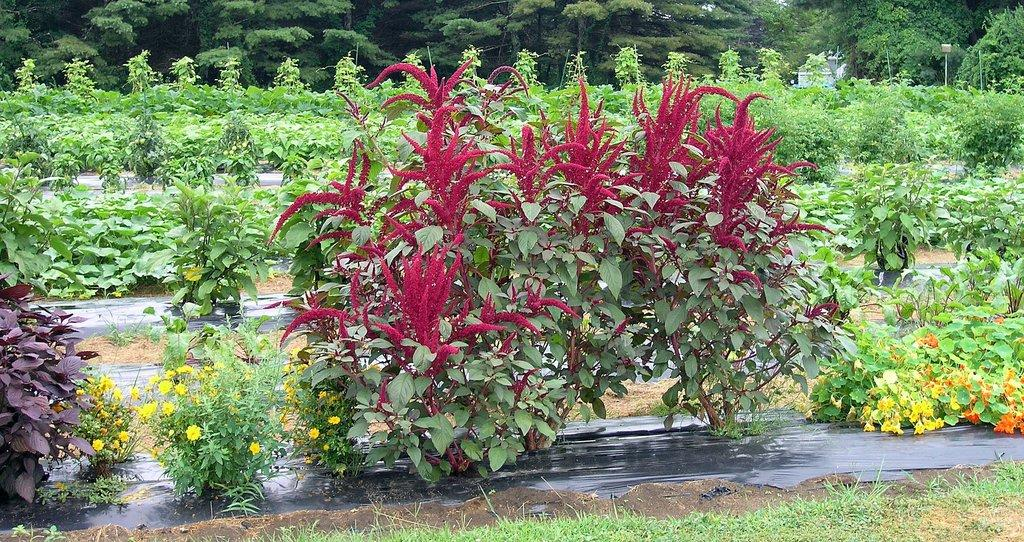What type of vegetation is present on the ground in the image? There are plants on the ground in the image. What other type of vegetation can be seen in the image? There are trees in the image. Can you see a rifle hidden among the plants in the image? There is no rifle present in the image; it only features plants and trees. What type of card is being used to identify the plants in the image? There is no card present in the image, as it only contains plants and trees. 